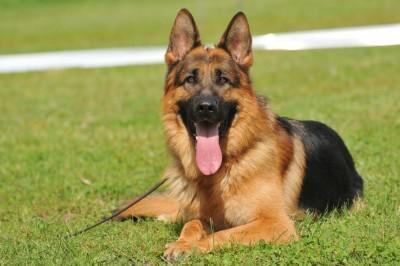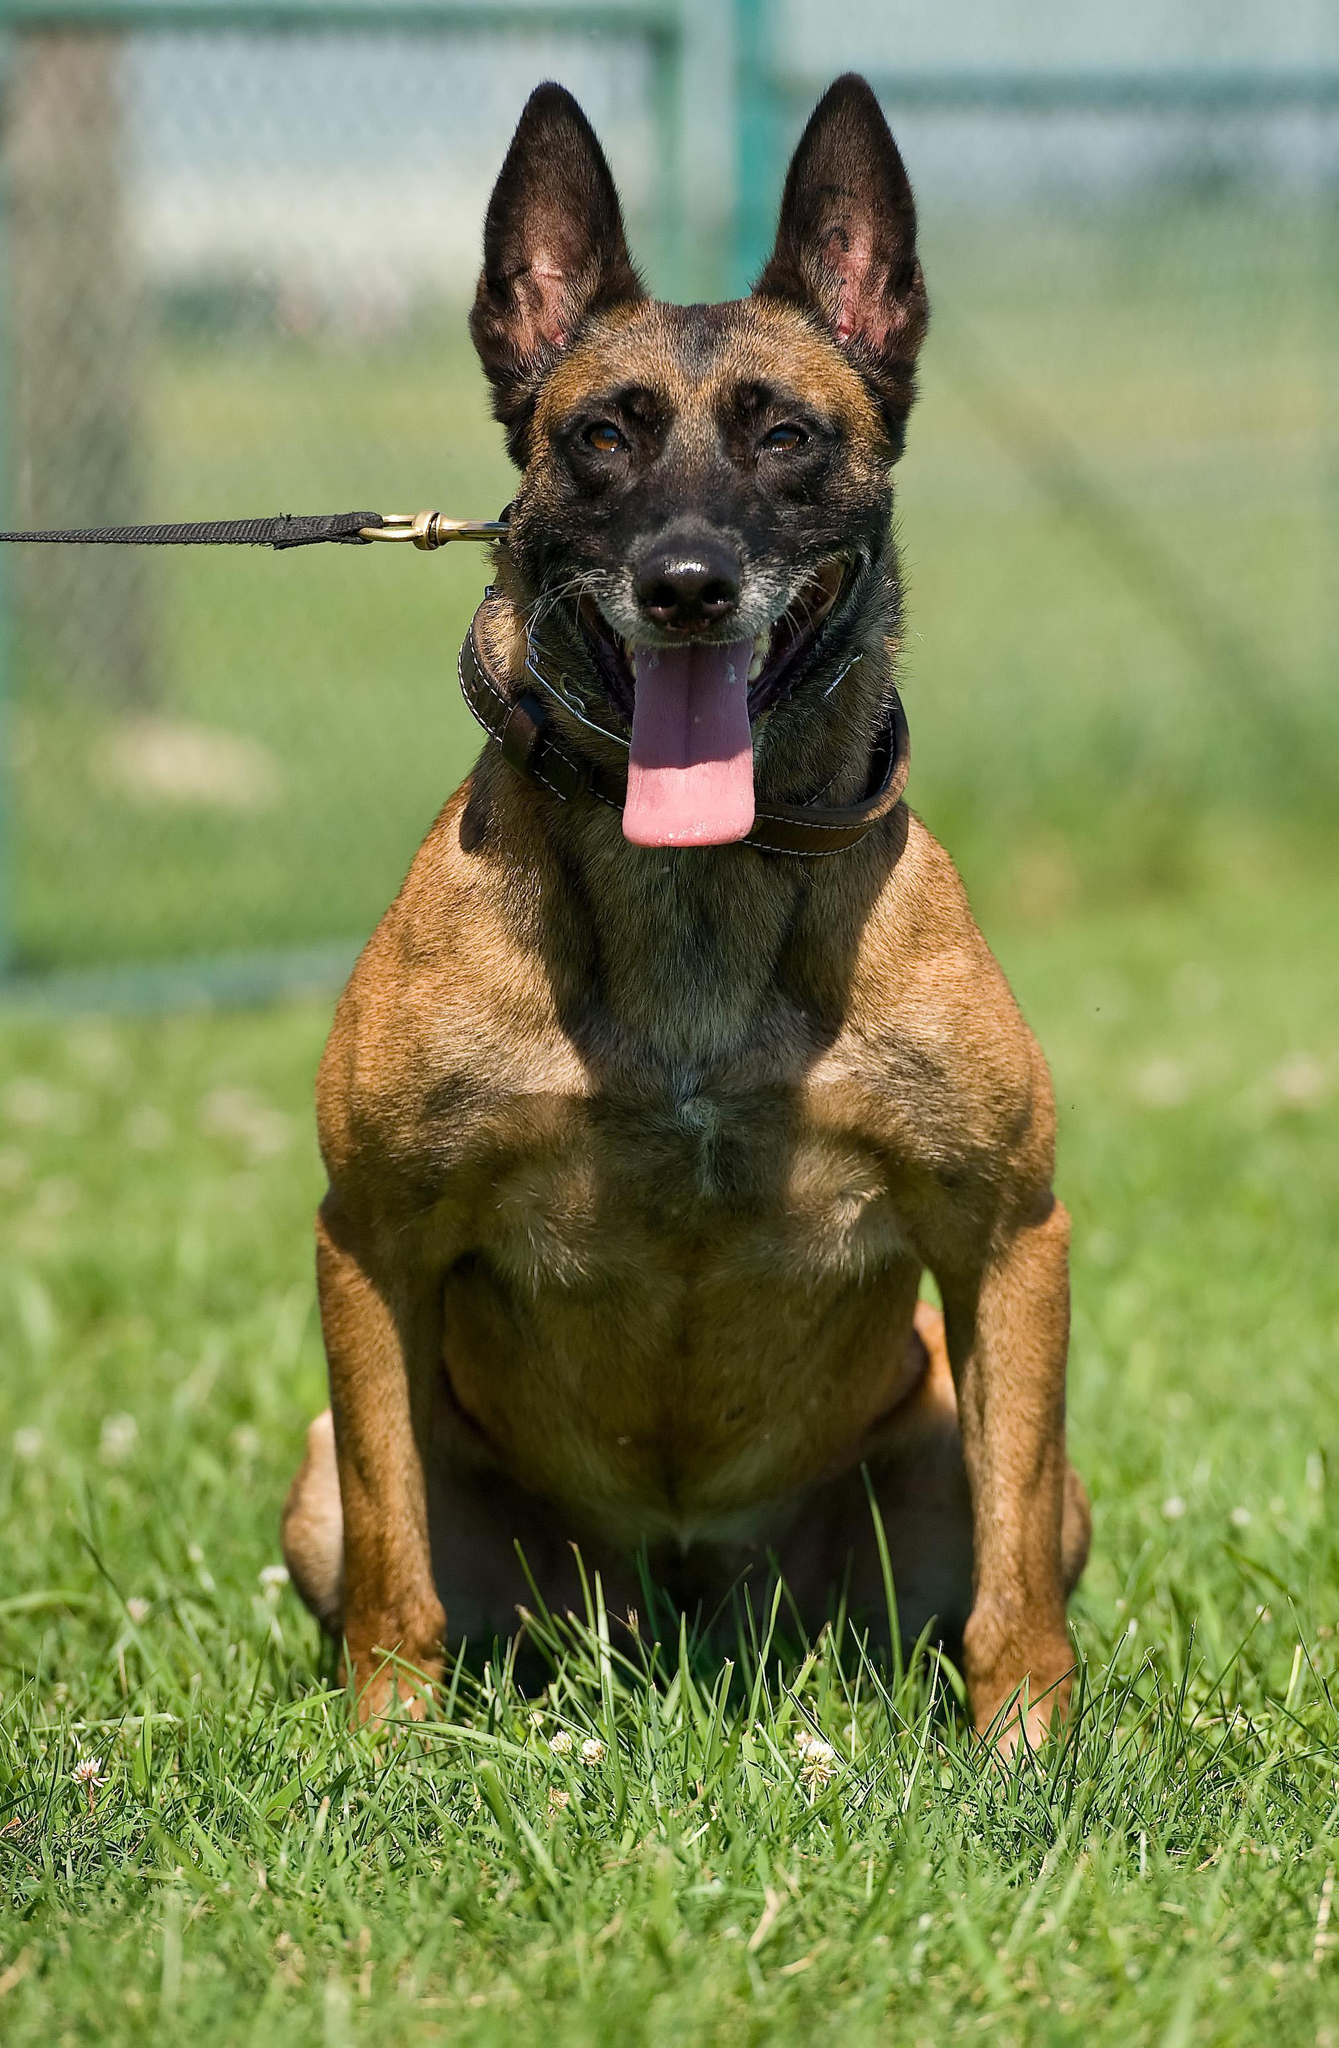The first image is the image on the left, the second image is the image on the right. Analyze the images presented: Is the assertion "There is a total of 1 German Shepard whose face and body are completely front facing." valid? Answer yes or no. Yes. The first image is the image on the left, the second image is the image on the right. For the images displayed, is the sentence "a dog is laying in the grass with a leash on" factually correct? Answer yes or no. Yes. 